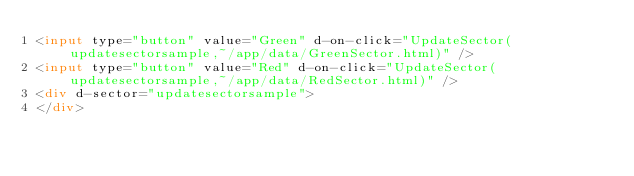Convert code to text. <code><loc_0><loc_0><loc_500><loc_500><_HTML_><input type="button" value="Green" d-on-click="UpdateSector(updatesectorsample,~/app/data/GreenSector.html)" />
<input type="button" value="Red" d-on-click="UpdateSector(updatesectorsample,~/app/data/RedSector.html)" />
<div d-sector="updatesectorsample">
</div>
</code> 